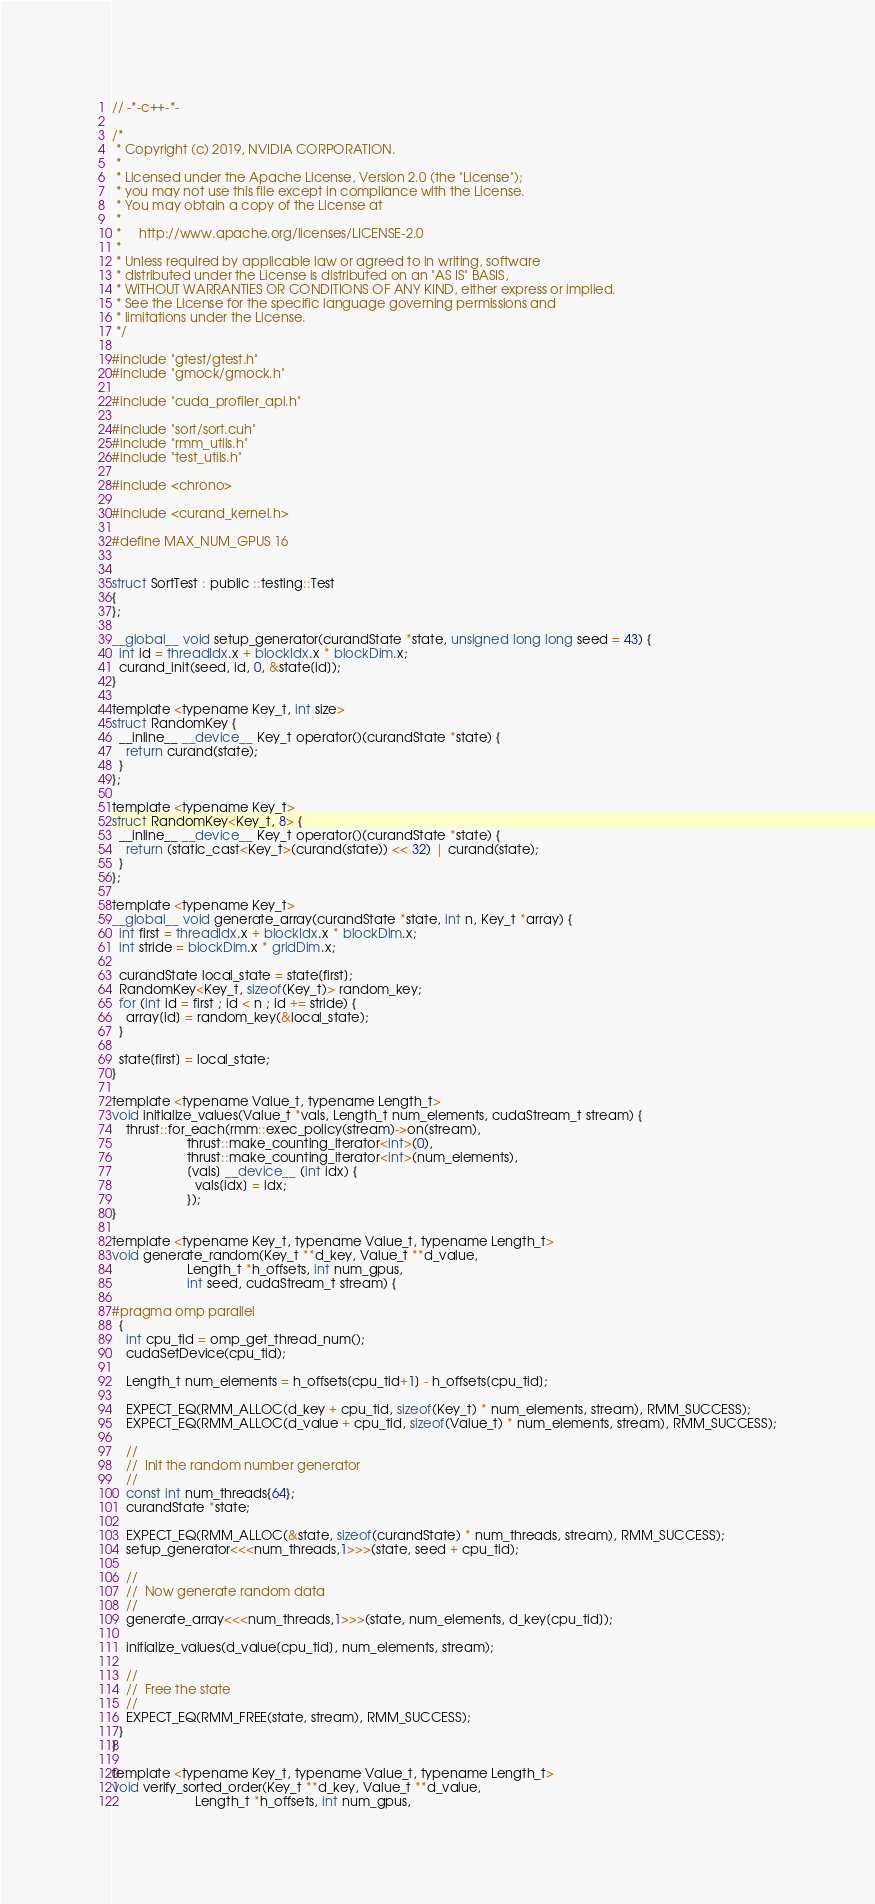Convert code to text. <code><loc_0><loc_0><loc_500><loc_500><_Cuda_>// -*-c++-*-

/*
 * Copyright (c) 2019, NVIDIA CORPORATION.
 *
 * Licensed under the Apache License, Version 2.0 (the "License");
 * you may not use this file except in compliance with the License.
 * You may obtain a copy of the License at
 *
 *     http://www.apache.org/licenses/LICENSE-2.0
 *
 * Unless required by applicable law or agreed to in writing, software
 * distributed under the License is distributed on an "AS IS" BASIS,
 * WITHOUT WARRANTIES OR CONDITIONS OF ANY KIND, either express or implied.
 * See the License for the specific language governing permissions and
 * limitations under the License.
 */

#include "gtest/gtest.h"
#include "gmock/gmock.h"

#include "cuda_profiler_api.h"

#include "sort/sort.cuh"
#include "rmm_utils.h"
#include "test_utils.h"

#include <chrono>

#include <curand_kernel.h>

#define MAX_NUM_GPUS 16


struct SortTest : public ::testing::Test
{
};

__global__ void setup_generator(curandState *state, unsigned long long seed = 43) {
  int id = threadIdx.x + blockIdx.x * blockDim.x;
  curand_init(seed, id, 0, &state[id]);
}

template <typename Key_t, int size>
struct RandomKey {
  __inline__ __device__ Key_t operator()(curandState *state) {
    return curand(state);
  }
};

template <typename Key_t>
struct RandomKey<Key_t, 8> {
  __inline__ __device__ Key_t operator()(curandState *state) {
    return (static_cast<Key_t>(curand(state)) << 32) | curand(state);
  }
};

template <typename Key_t>
__global__ void generate_array(curandState *state, int n, Key_t *array) {
  int first = threadIdx.x + blockIdx.x * blockDim.x;
  int stride = blockDim.x * gridDim.x;

  curandState local_state = state[first];
  RandomKey<Key_t, sizeof(Key_t)> random_key;
  for (int id = first ; id < n ; id += stride) {
    array[id] = random_key(&local_state);
  }

  state[first] = local_state;
}

template <typename Value_t, typename Length_t>
void initialize_values(Value_t *vals, Length_t num_elements, cudaStream_t stream) {
    thrust::for_each(rmm::exec_policy(stream)->on(stream),
                     thrust::make_counting_iterator<int>(0),
                     thrust::make_counting_iterator<int>(num_elements),
                     [vals] __device__ (int idx) {
                       vals[idx] = idx;
                     });
}

template <typename Key_t, typename Value_t, typename Length_t>
void generate_random(Key_t **d_key, Value_t **d_value,
                     Length_t *h_offsets, int num_gpus,
                     int seed, cudaStream_t stream) {

#pragma omp parallel
  {
    int cpu_tid = omp_get_thread_num();
    cudaSetDevice(cpu_tid);

    Length_t num_elements = h_offsets[cpu_tid+1] - h_offsets[cpu_tid];

    EXPECT_EQ(RMM_ALLOC(d_key + cpu_tid, sizeof(Key_t) * num_elements, stream), RMM_SUCCESS);
    EXPECT_EQ(RMM_ALLOC(d_value + cpu_tid, sizeof(Value_t) * num_elements, stream), RMM_SUCCESS);

    //
    //  Init the random number generator
    //
    const int num_threads{64};
    curandState *state;

    EXPECT_EQ(RMM_ALLOC(&state, sizeof(curandState) * num_threads, stream), RMM_SUCCESS);
    setup_generator<<<num_threads,1>>>(state, seed + cpu_tid);

    //
    //  Now generate random data
    //
    generate_array<<<num_threads,1>>>(state, num_elements, d_key[cpu_tid]);

    initialize_values(d_value[cpu_tid], num_elements, stream);
    
    //
    //  Free the state
    //
    EXPECT_EQ(RMM_FREE(state, stream), RMM_SUCCESS);
  }
}

template <typename Key_t, typename Value_t, typename Length_t>
void verify_sorted_order(Key_t **d_key, Value_t **d_value,
                       Length_t *h_offsets, int num_gpus,</code> 